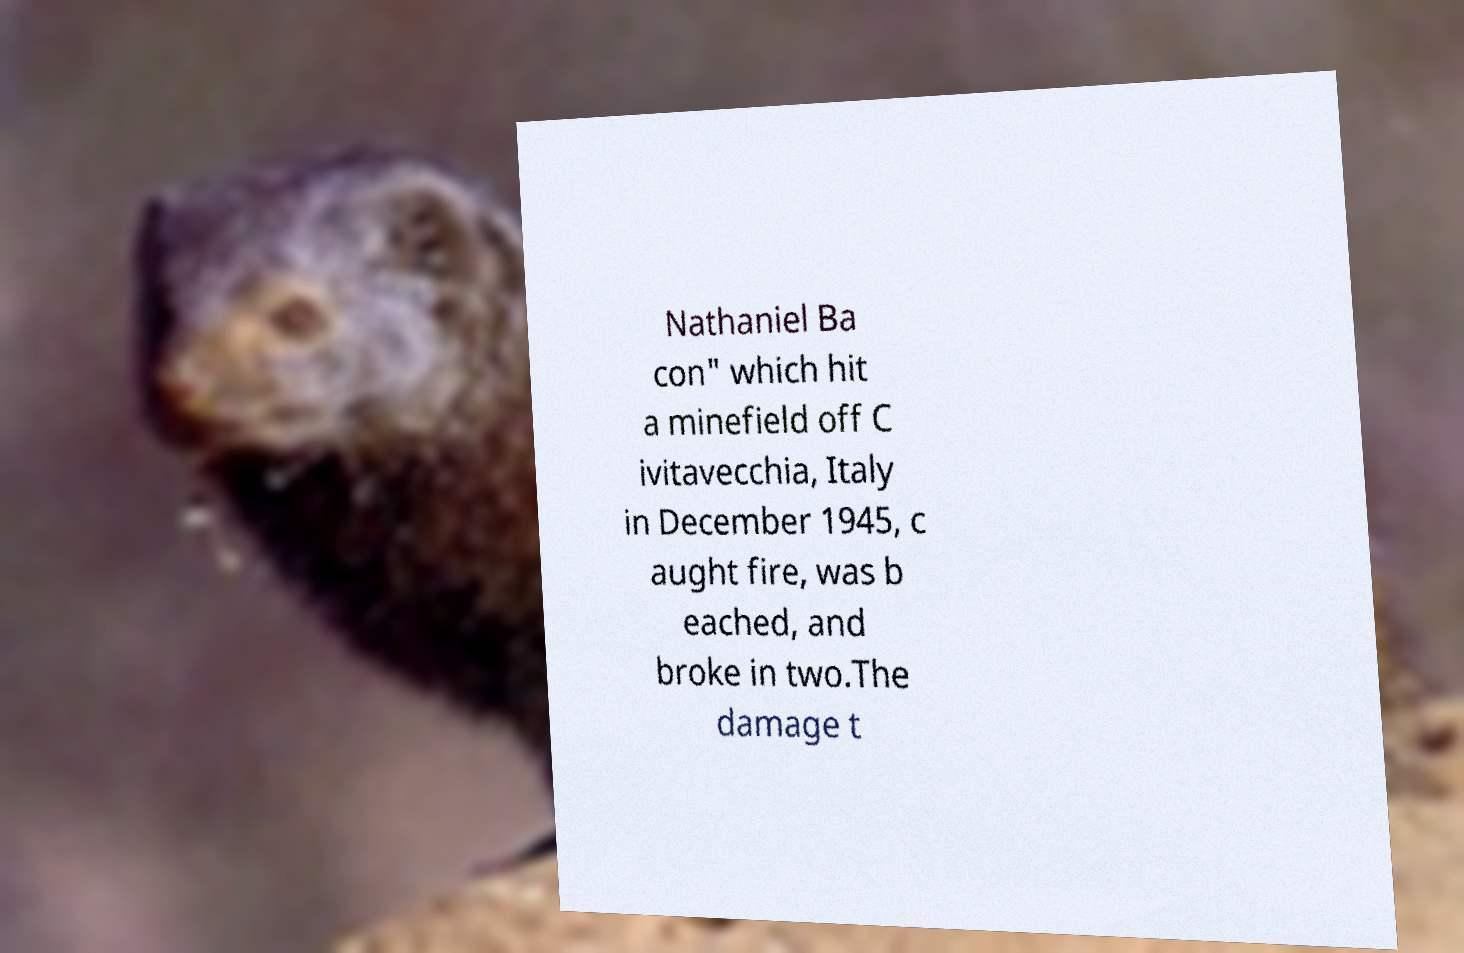Please identify and transcribe the text found in this image. Nathaniel Ba con" which hit a minefield off C ivitavecchia, Italy in December 1945, c aught fire, was b eached, and broke in two.The damage t 